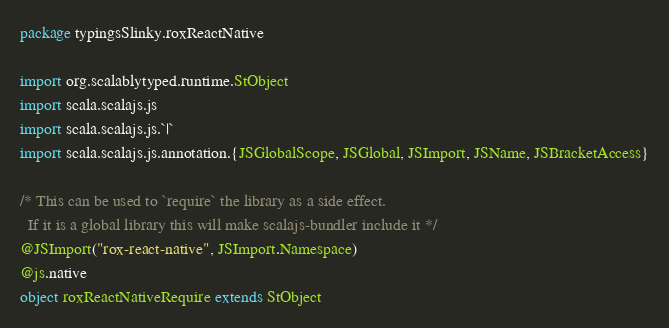<code> <loc_0><loc_0><loc_500><loc_500><_Scala_>package typingsSlinky.roxReactNative

import org.scalablytyped.runtime.StObject
import scala.scalajs.js
import scala.scalajs.js.`|`
import scala.scalajs.js.annotation.{JSGlobalScope, JSGlobal, JSImport, JSName, JSBracketAccess}

/* This can be used to `require` the library as a side effect.
  If it is a global library this will make scalajs-bundler include it */
@JSImport("rox-react-native", JSImport.Namespace)
@js.native
object roxReactNativeRequire extends StObject
</code> 